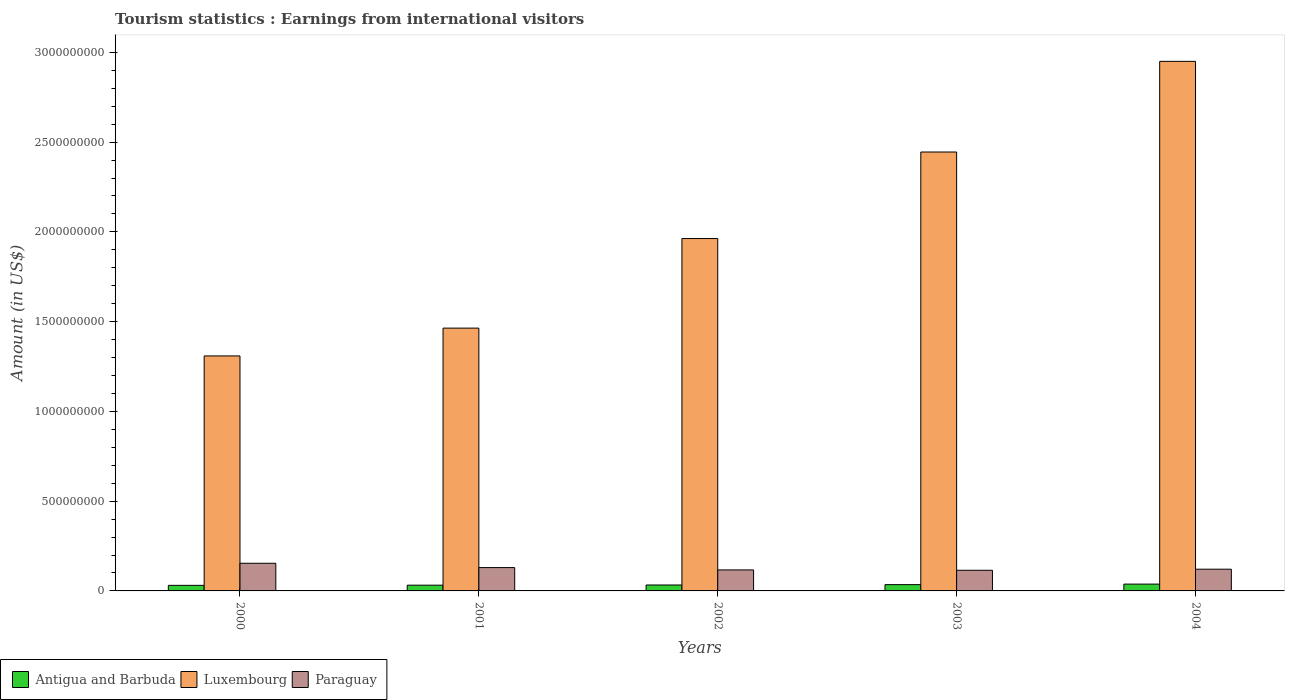Are the number of bars per tick equal to the number of legend labels?
Provide a succinct answer. Yes. How many bars are there on the 4th tick from the right?
Offer a terse response. 3. What is the earnings from international visitors in Paraguay in 2004?
Your answer should be very brief. 1.21e+08. Across all years, what is the maximum earnings from international visitors in Luxembourg?
Your answer should be compact. 2.95e+09. Across all years, what is the minimum earnings from international visitors in Luxembourg?
Offer a terse response. 1.31e+09. What is the total earnings from international visitors in Antigua and Barbuda in the graph?
Provide a short and direct response. 1.69e+08. What is the difference between the earnings from international visitors in Antigua and Barbuda in 2001 and that in 2002?
Provide a succinct answer. -1.00e+06. What is the difference between the earnings from international visitors in Luxembourg in 2000 and the earnings from international visitors in Antigua and Barbuda in 2004?
Your answer should be compact. 1.27e+09. What is the average earnings from international visitors in Antigua and Barbuda per year?
Your answer should be compact. 3.38e+07. In the year 2001, what is the difference between the earnings from international visitors in Paraguay and earnings from international visitors in Luxembourg?
Provide a succinct answer. -1.33e+09. In how many years, is the earnings from international visitors in Antigua and Barbuda greater than 1600000000 US$?
Your answer should be very brief. 0. What is the ratio of the earnings from international visitors in Antigua and Barbuda in 2001 to that in 2004?
Ensure brevity in your answer.  0.84. Is the earnings from international visitors in Luxembourg in 2002 less than that in 2003?
Your answer should be very brief. Yes. What is the difference between the highest and the second highest earnings from international visitors in Luxembourg?
Give a very brief answer. 5.05e+08. What is the difference between the highest and the lowest earnings from international visitors in Antigua and Barbuda?
Provide a succinct answer. 7.00e+06. In how many years, is the earnings from international visitors in Luxembourg greater than the average earnings from international visitors in Luxembourg taken over all years?
Your answer should be compact. 2. What does the 3rd bar from the left in 2004 represents?
Offer a very short reply. Paraguay. What does the 1st bar from the right in 2001 represents?
Offer a very short reply. Paraguay. Is it the case that in every year, the sum of the earnings from international visitors in Antigua and Barbuda and earnings from international visitors in Paraguay is greater than the earnings from international visitors in Luxembourg?
Offer a terse response. No. How many bars are there?
Give a very brief answer. 15. Are the values on the major ticks of Y-axis written in scientific E-notation?
Give a very brief answer. No. Does the graph contain grids?
Your answer should be very brief. No. Where does the legend appear in the graph?
Ensure brevity in your answer.  Bottom left. What is the title of the graph?
Keep it short and to the point. Tourism statistics : Earnings from international visitors. Does "Sub-Saharan Africa (all income levels)" appear as one of the legend labels in the graph?
Your answer should be very brief. No. What is the label or title of the Y-axis?
Your response must be concise. Amount (in US$). What is the Amount (in US$) of Antigua and Barbuda in 2000?
Your response must be concise. 3.10e+07. What is the Amount (in US$) in Luxembourg in 2000?
Provide a succinct answer. 1.31e+09. What is the Amount (in US$) of Paraguay in 2000?
Offer a very short reply. 1.54e+08. What is the Amount (in US$) of Antigua and Barbuda in 2001?
Provide a short and direct response. 3.20e+07. What is the Amount (in US$) in Luxembourg in 2001?
Give a very brief answer. 1.46e+09. What is the Amount (in US$) of Paraguay in 2001?
Provide a succinct answer. 1.30e+08. What is the Amount (in US$) in Antigua and Barbuda in 2002?
Make the answer very short. 3.30e+07. What is the Amount (in US$) of Luxembourg in 2002?
Your answer should be compact. 1.96e+09. What is the Amount (in US$) of Paraguay in 2002?
Offer a terse response. 1.17e+08. What is the Amount (in US$) of Antigua and Barbuda in 2003?
Provide a succinct answer. 3.50e+07. What is the Amount (in US$) in Luxembourg in 2003?
Give a very brief answer. 2.44e+09. What is the Amount (in US$) in Paraguay in 2003?
Ensure brevity in your answer.  1.15e+08. What is the Amount (in US$) of Antigua and Barbuda in 2004?
Offer a very short reply. 3.80e+07. What is the Amount (in US$) of Luxembourg in 2004?
Ensure brevity in your answer.  2.95e+09. What is the Amount (in US$) in Paraguay in 2004?
Give a very brief answer. 1.21e+08. Across all years, what is the maximum Amount (in US$) of Antigua and Barbuda?
Your answer should be very brief. 3.80e+07. Across all years, what is the maximum Amount (in US$) in Luxembourg?
Provide a short and direct response. 2.95e+09. Across all years, what is the maximum Amount (in US$) of Paraguay?
Keep it short and to the point. 1.54e+08. Across all years, what is the minimum Amount (in US$) in Antigua and Barbuda?
Your answer should be very brief. 3.10e+07. Across all years, what is the minimum Amount (in US$) in Luxembourg?
Offer a terse response. 1.31e+09. Across all years, what is the minimum Amount (in US$) of Paraguay?
Offer a very short reply. 1.15e+08. What is the total Amount (in US$) in Antigua and Barbuda in the graph?
Your answer should be very brief. 1.69e+08. What is the total Amount (in US$) in Luxembourg in the graph?
Your response must be concise. 1.01e+1. What is the total Amount (in US$) in Paraguay in the graph?
Keep it short and to the point. 6.37e+08. What is the difference between the Amount (in US$) in Luxembourg in 2000 and that in 2001?
Offer a very short reply. -1.55e+08. What is the difference between the Amount (in US$) in Paraguay in 2000 and that in 2001?
Offer a terse response. 2.40e+07. What is the difference between the Amount (in US$) in Luxembourg in 2000 and that in 2002?
Offer a very short reply. -6.54e+08. What is the difference between the Amount (in US$) in Paraguay in 2000 and that in 2002?
Your answer should be very brief. 3.70e+07. What is the difference between the Amount (in US$) in Luxembourg in 2000 and that in 2003?
Provide a succinct answer. -1.14e+09. What is the difference between the Amount (in US$) of Paraguay in 2000 and that in 2003?
Your answer should be very brief. 3.90e+07. What is the difference between the Amount (in US$) of Antigua and Barbuda in 2000 and that in 2004?
Your answer should be very brief. -7.00e+06. What is the difference between the Amount (in US$) in Luxembourg in 2000 and that in 2004?
Ensure brevity in your answer.  -1.64e+09. What is the difference between the Amount (in US$) in Paraguay in 2000 and that in 2004?
Make the answer very short. 3.30e+07. What is the difference between the Amount (in US$) in Luxembourg in 2001 and that in 2002?
Offer a very short reply. -4.99e+08. What is the difference between the Amount (in US$) of Paraguay in 2001 and that in 2002?
Offer a very short reply. 1.30e+07. What is the difference between the Amount (in US$) in Luxembourg in 2001 and that in 2003?
Ensure brevity in your answer.  -9.81e+08. What is the difference between the Amount (in US$) in Paraguay in 2001 and that in 2003?
Make the answer very short. 1.50e+07. What is the difference between the Amount (in US$) in Antigua and Barbuda in 2001 and that in 2004?
Your answer should be compact. -6.00e+06. What is the difference between the Amount (in US$) of Luxembourg in 2001 and that in 2004?
Offer a very short reply. -1.49e+09. What is the difference between the Amount (in US$) in Paraguay in 2001 and that in 2004?
Your response must be concise. 9.00e+06. What is the difference between the Amount (in US$) of Antigua and Barbuda in 2002 and that in 2003?
Give a very brief answer. -2.00e+06. What is the difference between the Amount (in US$) of Luxembourg in 2002 and that in 2003?
Give a very brief answer. -4.82e+08. What is the difference between the Amount (in US$) in Antigua and Barbuda in 2002 and that in 2004?
Give a very brief answer. -5.00e+06. What is the difference between the Amount (in US$) of Luxembourg in 2002 and that in 2004?
Your answer should be compact. -9.87e+08. What is the difference between the Amount (in US$) in Antigua and Barbuda in 2003 and that in 2004?
Make the answer very short. -3.00e+06. What is the difference between the Amount (in US$) of Luxembourg in 2003 and that in 2004?
Provide a short and direct response. -5.05e+08. What is the difference between the Amount (in US$) of Paraguay in 2003 and that in 2004?
Your answer should be compact. -6.00e+06. What is the difference between the Amount (in US$) in Antigua and Barbuda in 2000 and the Amount (in US$) in Luxembourg in 2001?
Give a very brief answer. -1.43e+09. What is the difference between the Amount (in US$) of Antigua and Barbuda in 2000 and the Amount (in US$) of Paraguay in 2001?
Offer a terse response. -9.90e+07. What is the difference between the Amount (in US$) in Luxembourg in 2000 and the Amount (in US$) in Paraguay in 2001?
Your answer should be very brief. 1.18e+09. What is the difference between the Amount (in US$) of Antigua and Barbuda in 2000 and the Amount (in US$) of Luxembourg in 2002?
Provide a succinct answer. -1.93e+09. What is the difference between the Amount (in US$) in Antigua and Barbuda in 2000 and the Amount (in US$) in Paraguay in 2002?
Give a very brief answer. -8.60e+07. What is the difference between the Amount (in US$) in Luxembourg in 2000 and the Amount (in US$) in Paraguay in 2002?
Give a very brief answer. 1.19e+09. What is the difference between the Amount (in US$) in Antigua and Barbuda in 2000 and the Amount (in US$) in Luxembourg in 2003?
Keep it short and to the point. -2.41e+09. What is the difference between the Amount (in US$) in Antigua and Barbuda in 2000 and the Amount (in US$) in Paraguay in 2003?
Offer a very short reply. -8.40e+07. What is the difference between the Amount (in US$) of Luxembourg in 2000 and the Amount (in US$) of Paraguay in 2003?
Your answer should be compact. 1.19e+09. What is the difference between the Amount (in US$) in Antigua and Barbuda in 2000 and the Amount (in US$) in Luxembourg in 2004?
Keep it short and to the point. -2.92e+09. What is the difference between the Amount (in US$) in Antigua and Barbuda in 2000 and the Amount (in US$) in Paraguay in 2004?
Make the answer very short. -9.00e+07. What is the difference between the Amount (in US$) of Luxembourg in 2000 and the Amount (in US$) of Paraguay in 2004?
Give a very brief answer. 1.19e+09. What is the difference between the Amount (in US$) in Antigua and Barbuda in 2001 and the Amount (in US$) in Luxembourg in 2002?
Your answer should be compact. -1.93e+09. What is the difference between the Amount (in US$) in Antigua and Barbuda in 2001 and the Amount (in US$) in Paraguay in 2002?
Make the answer very short. -8.50e+07. What is the difference between the Amount (in US$) in Luxembourg in 2001 and the Amount (in US$) in Paraguay in 2002?
Your response must be concise. 1.35e+09. What is the difference between the Amount (in US$) in Antigua and Barbuda in 2001 and the Amount (in US$) in Luxembourg in 2003?
Ensure brevity in your answer.  -2.41e+09. What is the difference between the Amount (in US$) of Antigua and Barbuda in 2001 and the Amount (in US$) of Paraguay in 2003?
Your answer should be very brief. -8.30e+07. What is the difference between the Amount (in US$) of Luxembourg in 2001 and the Amount (in US$) of Paraguay in 2003?
Give a very brief answer. 1.35e+09. What is the difference between the Amount (in US$) of Antigua and Barbuda in 2001 and the Amount (in US$) of Luxembourg in 2004?
Keep it short and to the point. -2.92e+09. What is the difference between the Amount (in US$) of Antigua and Barbuda in 2001 and the Amount (in US$) of Paraguay in 2004?
Offer a terse response. -8.90e+07. What is the difference between the Amount (in US$) in Luxembourg in 2001 and the Amount (in US$) in Paraguay in 2004?
Keep it short and to the point. 1.34e+09. What is the difference between the Amount (in US$) of Antigua and Barbuda in 2002 and the Amount (in US$) of Luxembourg in 2003?
Your answer should be very brief. -2.41e+09. What is the difference between the Amount (in US$) of Antigua and Barbuda in 2002 and the Amount (in US$) of Paraguay in 2003?
Provide a succinct answer. -8.20e+07. What is the difference between the Amount (in US$) in Luxembourg in 2002 and the Amount (in US$) in Paraguay in 2003?
Give a very brief answer. 1.85e+09. What is the difference between the Amount (in US$) in Antigua and Barbuda in 2002 and the Amount (in US$) in Luxembourg in 2004?
Offer a terse response. -2.92e+09. What is the difference between the Amount (in US$) in Antigua and Barbuda in 2002 and the Amount (in US$) in Paraguay in 2004?
Your answer should be compact. -8.80e+07. What is the difference between the Amount (in US$) in Luxembourg in 2002 and the Amount (in US$) in Paraguay in 2004?
Make the answer very short. 1.84e+09. What is the difference between the Amount (in US$) in Antigua and Barbuda in 2003 and the Amount (in US$) in Luxembourg in 2004?
Offer a very short reply. -2.92e+09. What is the difference between the Amount (in US$) of Antigua and Barbuda in 2003 and the Amount (in US$) of Paraguay in 2004?
Offer a terse response. -8.60e+07. What is the difference between the Amount (in US$) in Luxembourg in 2003 and the Amount (in US$) in Paraguay in 2004?
Offer a very short reply. 2.32e+09. What is the average Amount (in US$) in Antigua and Barbuda per year?
Give a very brief answer. 3.38e+07. What is the average Amount (in US$) of Luxembourg per year?
Provide a succinct answer. 2.03e+09. What is the average Amount (in US$) in Paraguay per year?
Offer a terse response. 1.27e+08. In the year 2000, what is the difference between the Amount (in US$) in Antigua and Barbuda and Amount (in US$) in Luxembourg?
Give a very brief answer. -1.28e+09. In the year 2000, what is the difference between the Amount (in US$) of Antigua and Barbuda and Amount (in US$) of Paraguay?
Your response must be concise. -1.23e+08. In the year 2000, what is the difference between the Amount (in US$) in Luxembourg and Amount (in US$) in Paraguay?
Offer a terse response. 1.16e+09. In the year 2001, what is the difference between the Amount (in US$) in Antigua and Barbuda and Amount (in US$) in Luxembourg?
Make the answer very short. -1.43e+09. In the year 2001, what is the difference between the Amount (in US$) of Antigua and Barbuda and Amount (in US$) of Paraguay?
Make the answer very short. -9.80e+07. In the year 2001, what is the difference between the Amount (in US$) in Luxembourg and Amount (in US$) in Paraguay?
Provide a short and direct response. 1.33e+09. In the year 2002, what is the difference between the Amount (in US$) in Antigua and Barbuda and Amount (in US$) in Luxembourg?
Offer a terse response. -1.93e+09. In the year 2002, what is the difference between the Amount (in US$) of Antigua and Barbuda and Amount (in US$) of Paraguay?
Offer a terse response. -8.40e+07. In the year 2002, what is the difference between the Amount (in US$) of Luxembourg and Amount (in US$) of Paraguay?
Your answer should be compact. 1.85e+09. In the year 2003, what is the difference between the Amount (in US$) of Antigua and Barbuda and Amount (in US$) of Luxembourg?
Your answer should be very brief. -2.41e+09. In the year 2003, what is the difference between the Amount (in US$) of Antigua and Barbuda and Amount (in US$) of Paraguay?
Offer a very short reply. -8.00e+07. In the year 2003, what is the difference between the Amount (in US$) in Luxembourg and Amount (in US$) in Paraguay?
Offer a very short reply. 2.33e+09. In the year 2004, what is the difference between the Amount (in US$) in Antigua and Barbuda and Amount (in US$) in Luxembourg?
Give a very brief answer. -2.91e+09. In the year 2004, what is the difference between the Amount (in US$) in Antigua and Barbuda and Amount (in US$) in Paraguay?
Your response must be concise. -8.30e+07. In the year 2004, what is the difference between the Amount (in US$) in Luxembourg and Amount (in US$) in Paraguay?
Make the answer very short. 2.83e+09. What is the ratio of the Amount (in US$) of Antigua and Barbuda in 2000 to that in 2001?
Your response must be concise. 0.97. What is the ratio of the Amount (in US$) in Luxembourg in 2000 to that in 2001?
Provide a succinct answer. 0.89. What is the ratio of the Amount (in US$) in Paraguay in 2000 to that in 2001?
Your answer should be very brief. 1.18. What is the ratio of the Amount (in US$) in Antigua and Barbuda in 2000 to that in 2002?
Offer a terse response. 0.94. What is the ratio of the Amount (in US$) in Luxembourg in 2000 to that in 2002?
Provide a short and direct response. 0.67. What is the ratio of the Amount (in US$) in Paraguay in 2000 to that in 2002?
Your response must be concise. 1.32. What is the ratio of the Amount (in US$) of Antigua and Barbuda in 2000 to that in 2003?
Ensure brevity in your answer.  0.89. What is the ratio of the Amount (in US$) in Luxembourg in 2000 to that in 2003?
Give a very brief answer. 0.54. What is the ratio of the Amount (in US$) of Paraguay in 2000 to that in 2003?
Keep it short and to the point. 1.34. What is the ratio of the Amount (in US$) in Antigua and Barbuda in 2000 to that in 2004?
Provide a short and direct response. 0.82. What is the ratio of the Amount (in US$) in Luxembourg in 2000 to that in 2004?
Make the answer very short. 0.44. What is the ratio of the Amount (in US$) of Paraguay in 2000 to that in 2004?
Give a very brief answer. 1.27. What is the ratio of the Amount (in US$) in Antigua and Barbuda in 2001 to that in 2002?
Give a very brief answer. 0.97. What is the ratio of the Amount (in US$) in Luxembourg in 2001 to that in 2002?
Your response must be concise. 0.75. What is the ratio of the Amount (in US$) in Antigua and Barbuda in 2001 to that in 2003?
Make the answer very short. 0.91. What is the ratio of the Amount (in US$) in Luxembourg in 2001 to that in 2003?
Make the answer very short. 0.6. What is the ratio of the Amount (in US$) in Paraguay in 2001 to that in 2003?
Ensure brevity in your answer.  1.13. What is the ratio of the Amount (in US$) of Antigua and Barbuda in 2001 to that in 2004?
Keep it short and to the point. 0.84. What is the ratio of the Amount (in US$) of Luxembourg in 2001 to that in 2004?
Your answer should be compact. 0.5. What is the ratio of the Amount (in US$) in Paraguay in 2001 to that in 2004?
Keep it short and to the point. 1.07. What is the ratio of the Amount (in US$) in Antigua and Barbuda in 2002 to that in 2003?
Give a very brief answer. 0.94. What is the ratio of the Amount (in US$) in Luxembourg in 2002 to that in 2003?
Keep it short and to the point. 0.8. What is the ratio of the Amount (in US$) of Paraguay in 2002 to that in 2003?
Your answer should be compact. 1.02. What is the ratio of the Amount (in US$) of Antigua and Barbuda in 2002 to that in 2004?
Provide a short and direct response. 0.87. What is the ratio of the Amount (in US$) in Luxembourg in 2002 to that in 2004?
Offer a very short reply. 0.67. What is the ratio of the Amount (in US$) of Paraguay in 2002 to that in 2004?
Your response must be concise. 0.97. What is the ratio of the Amount (in US$) of Antigua and Barbuda in 2003 to that in 2004?
Your response must be concise. 0.92. What is the ratio of the Amount (in US$) of Luxembourg in 2003 to that in 2004?
Make the answer very short. 0.83. What is the ratio of the Amount (in US$) of Paraguay in 2003 to that in 2004?
Your response must be concise. 0.95. What is the difference between the highest and the second highest Amount (in US$) of Luxembourg?
Your answer should be very brief. 5.05e+08. What is the difference between the highest and the second highest Amount (in US$) in Paraguay?
Provide a short and direct response. 2.40e+07. What is the difference between the highest and the lowest Amount (in US$) of Luxembourg?
Offer a terse response. 1.64e+09. What is the difference between the highest and the lowest Amount (in US$) in Paraguay?
Your response must be concise. 3.90e+07. 